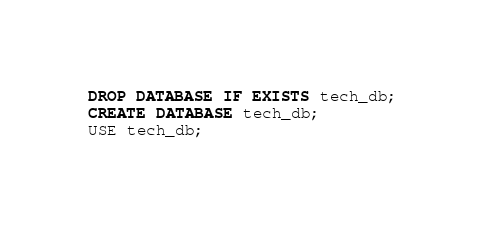Convert code to text. <code><loc_0><loc_0><loc_500><loc_500><_SQL_>DROP DATABASE IF EXISTS tech_db;
CREATE DATABASE tech_db;
USE tech_db;
</code> 